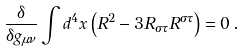Convert formula to latex. <formula><loc_0><loc_0><loc_500><loc_500>\frac { \delta } { \delta g _ { \mu \nu } } \int d ^ { 4 } x \left ( R ^ { 2 } - 3 R _ { \sigma \tau } R ^ { \sigma \tau } \right ) = 0 \, .</formula> 